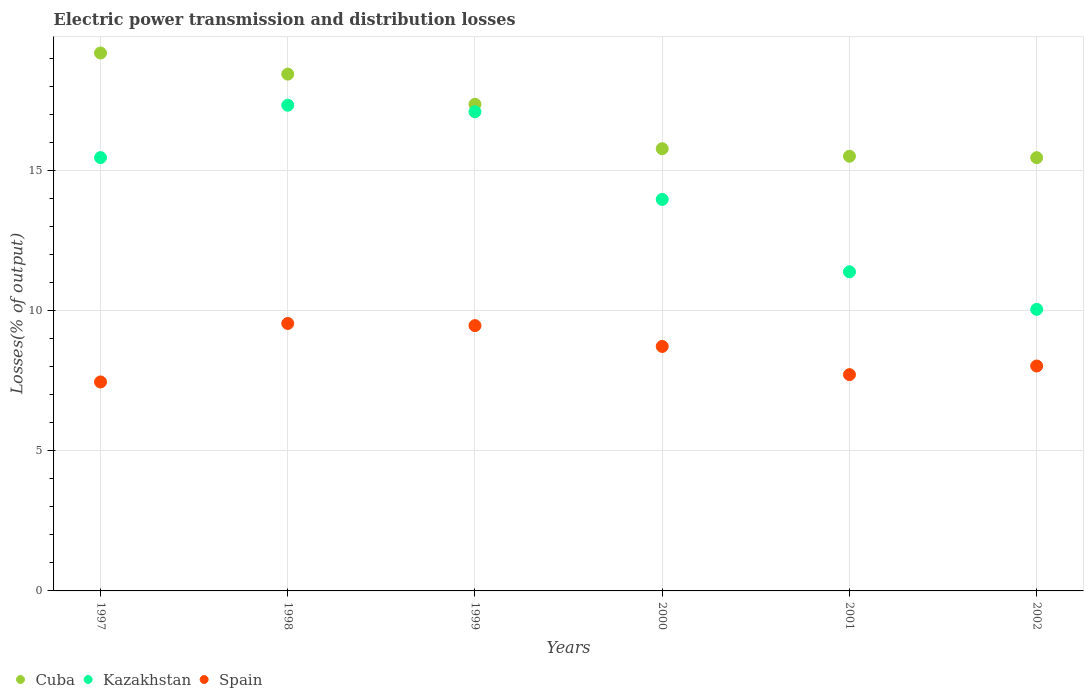What is the electric power transmission and distribution losses in Kazakhstan in 2002?
Your answer should be compact. 10.04. Across all years, what is the maximum electric power transmission and distribution losses in Spain?
Keep it short and to the point. 9.54. Across all years, what is the minimum electric power transmission and distribution losses in Cuba?
Offer a very short reply. 15.45. What is the total electric power transmission and distribution losses in Spain in the graph?
Your answer should be very brief. 50.91. What is the difference between the electric power transmission and distribution losses in Kazakhstan in 1997 and that in 2000?
Ensure brevity in your answer.  1.49. What is the difference between the electric power transmission and distribution losses in Spain in 1999 and the electric power transmission and distribution losses in Cuba in 2000?
Make the answer very short. -6.31. What is the average electric power transmission and distribution losses in Spain per year?
Ensure brevity in your answer.  8.49. In the year 2001, what is the difference between the electric power transmission and distribution losses in Spain and electric power transmission and distribution losses in Cuba?
Ensure brevity in your answer.  -7.79. What is the ratio of the electric power transmission and distribution losses in Spain in 2000 to that in 2001?
Offer a terse response. 1.13. Is the electric power transmission and distribution losses in Kazakhstan in 1999 less than that in 2000?
Your answer should be very brief. No. Is the difference between the electric power transmission and distribution losses in Spain in 1999 and 2001 greater than the difference between the electric power transmission and distribution losses in Cuba in 1999 and 2001?
Keep it short and to the point. No. What is the difference between the highest and the second highest electric power transmission and distribution losses in Spain?
Ensure brevity in your answer.  0.08. What is the difference between the highest and the lowest electric power transmission and distribution losses in Cuba?
Provide a short and direct response. 3.73. In how many years, is the electric power transmission and distribution losses in Kazakhstan greater than the average electric power transmission and distribution losses in Kazakhstan taken over all years?
Your answer should be very brief. 3. Does the electric power transmission and distribution losses in Cuba monotonically increase over the years?
Keep it short and to the point. No. Is the electric power transmission and distribution losses in Spain strictly greater than the electric power transmission and distribution losses in Kazakhstan over the years?
Ensure brevity in your answer.  No. How many dotlines are there?
Your answer should be compact. 3. How many years are there in the graph?
Keep it short and to the point. 6. What is the difference between two consecutive major ticks on the Y-axis?
Your answer should be very brief. 5. Where does the legend appear in the graph?
Give a very brief answer. Bottom left. What is the title of the graph?
Your answer should be compact. Electric power transmission and distribution losses. Does "United States" appear as one of the legend labels in the graph?
Give a very brief answer. No. What is the label or title of the X-axis?
Provide a succinct answer. Years. What is the label or title of the Y-axis?
Your response must be concise. Losses(% of output). What is the Losses(% of output) in Cuba in 1997?
Offer a terse response. 19.19. What is the Losses(% of output) in Kazakhstan in 1997?
Offer a terse response. 15.46. What is the Losses(% of output) of Spain in 1997?
Provide a short and direct response. 7.45. What is the Losses(% of output) of Cuba in 1998?
Your response must be concise. 18.43. What is the Losses(% of output) of Kazakhstan in 1998?
Your answer should be very brief. 17.32. What is the Losses(% of output) of Spain in 1998?
Ensure brevity in your answer.  9.54. What is the Losses(% of output) in Cuba in 1999?
Offer a very short reply. 17.35. What is the Losses(% of output) in Kazakhstan in 1999?
Your answer should be compact. 17.09. What is the Losses(% of output) in Spain in 1999?
Offer a very short reply. 9.46. What is the Losses(% of output) in Cuba in 2000?
Your response must be concise. 15.77. What is the Losses(% of output) in Kazakhstan in 2000?
Make the answer very short. 13.96. What is the Losses(% of output) of Spain in 2000?
Give a very brief answer. 8.72. What is the Losses(% of output) in Cuba in 2001?
Your answer should be very brief. 15.5. What is the Losses(% of output) in Kazakhstan in 2001?
Give a very brief answer. 11.38. What is the Losses(% of output) in Spain in 2001?
Offer a terse response. 7.71. What is the Losses(% of output) in Cuba in 2002?
Your answer should be compact. 15.45. What is the Losses(% of output) of Kazakhstan in 2002?
Offer a terse response. 10.04. What is the Losses(% of output) in Spain in 2002?
Your response must be concise. 8.02. Across all years, what is the maximum Losses(% of output) in Cuba?
Give a very brief answer. 19.19. Across all years, what is the maximum Losses(% of output) in Kazakhstan?
Ensure brevity in your answer.  17.32. Across all years, what is the maximum Losses(% of output) of Spain?
Give a very brief answer. 9.54. Across all years, what is the minimum Losses(% of output) in Cuba?
Your response must be concise. 15.45. Across all years, what is the minimum Losses(% of output) in Kazakhstan?
Keep it short and to the point. 10.04. Across all years, what is the minimum Losses(% of output) of Spain?
Ensure brevity in your answer.  7.45. What is the total Losses(% of output) in Cuba in the graph?
Make the answer very short. 101.7. What is the total Losses(% of output) of Kazakhstan in the graph?
Your answer should be compact. 85.26. What is the total Losses(% of output) of Spain in the graph?
Your response must be concise. 50.91. What is the difference between the Losses(% of output) in Cuba in 1997 and that in 1998?
Your answer should be very brief. 0.75. What is the difference between the Losses(% of output) of Kazakhstan in 1997 and that in 1998?
Your answer should be compact. -1.87. What is the difference between the Losses(% of output) in Spain in 1997 and that in 1998?
Keep it short and to the point. -2.09. What is the difference between the Losses(% of output) in Cuba in 1997 and that in 1999?
Make the answer very short. 1.83. What is the difference between the Losses(% of output) of Kazakhstan in 1997 and that in 1999?
Your response must be concise. -1.64. What is the difference between the Losses(% of output) of Spain in 1997 and that in 1999?
Provide a short and direct response. -2.01. What is the difference between the Losses(% of output) in Cuba in 1997 and that in 2000?
Offer a very short reply. 3.41. What is the difference between the Losses(% of output) in Kazakhstan in 1997 and that in 2000?
Keep it short and to the point. 1.49. What is the difference between the Losses(% of output) of Spain in 1997 and that in 2000?
Make the answer very short. -1.27. What is the difference between the Losses(% of output) of Cuba in 1997 and that in 2001?
Your answer should be very brief. 3.68. What is the difference between the Losses(% of output) in Kazakhstan in 1997 and that in 2001?
Keep it short and to the point. 4.07. What is the difference between the Losses(% of output) of Spain in 1997 and that in 2001?
Ensure brevity in your answer.  -0.26. What is the difference between the Losses(% of output) in Cuba in 1997 and that in 2002?
Give a very brief answer. 3.73. What is the difference between the Losses(% of output) in Kazakhstan in 1997 and that in 2002?
Offer a very short reply. 5.41. What is the difference between the Losses(% of output) of Spain in 1997 and that in 2002?
Your answer should be very brief. -0.57. What is the difference between the Losses(% of output) in Cuba in 1998 and that in 1999?
Your answer should be compact. 1.08. What is the difference between the Losses(% of output) in Kazakhstan in 1998 and that in 1999?
Provide a short and direct response. 0.23. What is the difference between the Losses(% of output) of Spain in 1998 and that in 1999?
Provide a succinct answer. 0.08. What is the difference between the Losses(% of output) in Cuba in 1998 and that in 2000?
Provide a succinct answer. 2.66. What is the difference between the Losses(% of output) of Kazakhstan in 1998 and that in 2000?
Ensure brevity in your answer.  3.36. What is the difference between the Losses(% of output) of Spain in 1998 and that in 2000?
Keep it short and to the point. 0.82. What is the difference between the Losses(% of output) of Cuba in 1998 and that in 2001?
Ensure brevity in your answer.  2.93. What is the difference between the Losses(% of output) of Kazakhstan in 1998 and that in 2001?
Offer a terse response. 5.94. What is the difference between the Losses(% of output) in Spain in 1998 and that in 2001?
Your answer should be compact. 1.82. What is the difference between the Losses(% of output) in Cuba in 1998 and that in 2002?
Ensure brevity in your answer.  2.98. What is the difference between the Losses(% of output) in Kazakhstan in 1998 and that in 2002?
Offer a very short reply. 7.28. What is the difference between the Losses(% of output) of Spain in 1998 and that in 2002?
Provide a succinct answer. 1.52. What is the difference between the Losses(% of output) in Cuba in 1999 and that in 2000?
Provide a succinct answer. 1.58. What is the difference between the Losses(% of output) in Kazakhstan in 1999 and that in 2000?
Your answer should be very brief. 3.13. What is the difference between the Losses(% of output) of Spain in 1999 and that in 2000?
Your answer should be very brief. 0.74. What is the difference between the Losses(% of output) of Cuba in 1999 and that in 2001?
Your answer should be very brief. 1.85. What is the difference between the Losses(% of output) of Kazakhstan in 1999 and that in 2001?
Provide a succinct answer. 5.71. What is the difference between the Losses(% of output) in Spain in 1999 and that in 2001?
Offer a very short reply. 1.75. What is the difference between the Losses(% of output) of Cuba in 1999 and that in 2002?
Provide a short and direct response. 1.9. What is the difference between the Losses(% of output) in Kazakhstan in 1999 and that in 2002?
Make the answer very short. 7.05. What is the difference between the Losses(% of output) in Spain in 1999 and that in 2002?
Provide a short and direct response. 1.44. What is the difference between the Losses(% of output) in Cuba in 2000 and that in 2001?
Provide a short and direct response. 0.27. What is the difference between the Losses(% of output) in Kazakhstan in 2000 and that in 2001?
Your response must be concise. 2.58. What is the difference between the Losses(% of output) of Cuba in 2000 and that in 2002?
Your answer should be compact. 0.32. What is the difference between the Losses(% of output) of Kazakhstan in 2000 and that in 2002?
Give a very brief answer. 3.92. What is the difference between the Losses(% of output) of Spain in 2000 and that in 2002?
Your response must be concise. 0.7. What is the difference between the Losses(% of output) in Cuba in 2001 and that in 2002?
Offer a terse response. 0.05. What is the difference between the Losses(% of output) of Kazakhstan in 2001 and that in 2002?
Make the answer very short. 1.34. What is the difference between the Losses(% of output) of Spain in 2001 and that in 2002?
Offer a terse response. -0.31. What is the difference between the Losses(% of output) in Cuba in 1997 and the Losses(% of output) in Kazakhstan in 1998?
Your response must be concise. 1.86. What is the difference between the Losses(% of output) in Cuba in 1997 and the Losses(% of output) in Spain in 1998?
Keep it short and to the point. 9.65. What is the difference between the Losses(% of output) of Kazakhstan in 1997 and the Losses(% of output) of Spain in 1998?
Offer a very short reply. 5.92. What is the difference between the Losses(% of output) of Cuba in 1997 and the Losses(% of output) of Kazakhstan in 1999?
Your answer should be compact. 2.09. What is the difference between the Losses(% of output) of Cuba in 1997 and the Losses(% of output) of Spain in 1999?
Ensure brevity in your answer.  9.72. What is the difference between the Losses(% of output) of Kazakhstan in 1997 and the Losses(% of output) of Spain in 1999?
Offer a very short reply. 5.99. What is the difference between the Losses(% of output) in Cuba in 1997 and the Losses(% of output) in Kazakhstan in 2000?
Ensure brevity in your answer.  5.22. What is the difference between the Losses(% of output) of Cuba in 1997 and the Losses(% of output) of Spain in 2000?
Give a very brief answer. 10.46. What is the difference between the Losses(% of output) in Kazakhstan in 1997 and the Losses(% of output) in Spain in 2000?
Make the answer very short. 6.74. What is the difference between the Losses(% of output) in Cuba in 1997 and the Losses(% of output) in Kazakhstan in 2001?
Give a very brief answer. 7.8. What is the difference between the Losses(% of output) in Cuba in 1997 and the Losses(% of output) in Spain in 2001?
Ensure brevity in your answer.  11.47. What is the difference between the Losses(% of output) of Kazakhstan in 1997 and the Losses(% of output) of Spain in 2001?
Your answer should be very brief. 7.74. What is the difference between the Losses(% of output) of Cuba in 1997 and the Losses(% of output) of Kazakhstan in 2002?
Provide a short and direct response. 9.14. What is the difference between the Losses(% of output) of Cuba in 1997 and the Losses(% of output) of Spain in 2002?
Give a very brief answer. 11.16. What is the difference between the Losses(% of output) in Kazakhstan in 1997 and the Losses(% of output) in Spain in 2002?
Provide a succinct answer. 7.43. What is the difference between the Losses(% of output) in Cuba in 1998 and the Losses(% of output) in Kazakhstan in 1999?
Your answer should be compact. 1.34. What is the difference between the Losses(% of output) of Cuba in 1998 and the Losses(% of output) of Spain in 1999?
Ensure brevity in your answer.  8.97. What is the difference between the Losses(% of output) in Kazakhstan in 1998 and the Losses(% of output) in Spain in 1999?
Keep it short and to the point. 7.86. What is the difference between the Losses(% of output) of Cuba in 1998 and the Losses(% of output) of Kazakhstan in 2000?
Ensure brevity in your answer.  4.47. What is the difference between the Losses(% of output) of Cuba in 1998 and the Losses(% of output) of Spain in 2000?
Make the answer very short. 9.71. What is the difference between the Losses(% of output) in Kazakhstan in 1998 and the Losses(% of output) in Spain in 2000?
Make the answer very short. 8.6. What is the difference between the Losses(% of output) of Cuba in 1998 and the Losses(% of output) of Kazakhstan in 2001?
Provide a short and direct response. 7.05. What is the difference between the Losses(% of output) in Cuba in 1998 and the Losses(% of output) in Spain in 2001?
Provide a succinct answer. 10.72. What is the difference between the Losses(% of output) of Kazakhstan in 1998 and the Losses(% of output) of Spain in 2001?
Your response must be concise. 9.61. What is the difference between the Losses(% of output) in Cuba in 1998 and the Losses(% of output) in Kazakhstan in 2002?
Provide a succinct answer. 8.39. What is the difference between the Losses(% of output) in Cuba in 1998 and the Losses(% of output) in Spain in 2002?
Your answer should be compact. 10.41. What is the difference between the Losses(% of output) of Kazakhstan in 1998 and the Losses(% of output) of Spain in 2002?
Keep it short and to the point. 9.3. What is the difference between the Losses(% of output) in Cuba in 1999 and the Losses(% of output) in Kazakhstan in 2000?
Provide a succinct answer. 3.39. What is the difference between the Losses(% of output) in Cuba in 1999 and the Losses(% of output) in Spain in 2000?
Your answer should be very brief. 8.63. What is the difference between the Losses(% of output) of Kazakhstan in 1999 and the Losses(% of output) of Spain in 2000?
Your answer should be very brief. 8.37. What is the difference between the Losses(% of output) in Cuba in 1999 and the Losses(% of output) in Kazakhstan in 2001?
Your response must be concise. 5.97. What is the difference between the Losses(% of output) in Cuba in 1999 and the Losses(% of output) in Spain in 2001?
Your response must be concise. 9.64. What is the difference between the Losses(% of output) in Kazakhstan in 1999 and the Losses(% of output) in Spain in 2001?
Your response must be concise. 9.38. What is the difference between the Losses(% of output) of Cuba in 1999 and the Losses(% of output) of Kazakhstan in 2002?
Make the answer very short. 7.31. What is the difference between the Losses(% of output) in Cuba in 1999 and the Losses(% of output) in Spain in 2002?
Keep it short and to the point. 9.33. What is the difference between the Losses(% of output) of Kazakhstan in 1999 and the Losses(% of output) of Spain in 2002?
Provide a short and direct response. 9.07. What is the difference between the Losses(% of output) of Cuba in 2000 and the Losses(% of output) of Kazakhstan in 2001?
Your response must be concise. 4.39. What is the difference between the Losses(% of output) of Cuba in 2000 and the Losses(% of output) of Spain in 2001?
Provide a succinct answer. 8.06. What is the difference between the Losses(% of output) of Kazakhstan in 2000 and the Losses(% of output) of Spain in 2001?
Your answer should be compact. 6.25. What is the difference between the Losses(% of output) in Cuba in 2000 and the Losses(% of output) in Kazakhstan in 2002?
Keep it short and to the point. 5.73. What is the difference between the Losses(% of output) of Cuba in 2000 and the Losses(% of output) of Spain in 2002?
Provide a short and direct response. 7.75. What is the difference between the Losses(% of output) in Kazakhstan in 2000 and the Losses(% of output) in Spain in 2002?
Provide a short and direct response. 5.94. What is the difference between the Losses(% of output) in Cuba in 2001 and the Losses(% of output) in Kazakhstan in 2002?
Keep it short and to the point. 5.46. What is the difference between the Losses(% of output) of Cuba in 2001 and the Losses(% of output) of Spain in 2002?
Ensure brevity in your answer.  7.48. What is the difference between the Losses(% of output) in Kazakhstan in 2001 and the Losses(% of output) in Spain in 2002?
Give a very brief answer. 3.36. What is the average Losses(% of output) of Cuba per year?
Provide a succinct answer. 16.95. What is the average Losses(% of output) of Kazakhstan per year?
Keep it short and to the point. 14.21. What is the average Losses(% of output) of Spain per year?
Your response must be concise. 8.49. In the year 1997, what is the difference between the Losses(% of output) of Cuba and Losses(% of output) of Kazakhstan?
Keep it short and to the point. 3.73. In the year 1997, what is the difference between the Losses(% of output) in Cuba and Losses(% of output) in Spain?
Your response must be concise. 11.73. In the year 1997, what is the difference between the Losses(% of output) in Kazakhstan and Losses(% of output) in Spain?
Your answer should be compact. 8. In the year 1998, what is the difference between the Losses(% of output) in Cuba and Losses(% of output) in Kazakhstan?
Offer a terse response. 1.11. In the year 1998, what is the difference between the Losses(% of output) of Cuba and Losses(% of output) of Spain?
Keep it short and to the point. 8.89. In the year 1998, what is the difference between the Losses(% of output) of Kazakhstan and Losses(% of output) of Spain?
Keep it short and to the point. 7.79. In the year 1999, what is the difference between the Losses(% of output) of Cuba and Losses(% of output) of Kazakhstan?
Your answer should be compact. 0.26. In the year 1999, what is the difference between the Losses(% of output) of Cuba and Losses(% of output) of Spain?
Make the answer very short. 7.89. In the year 1999, what is the difference between the Losses(% of output) of Kazakhstan and Losses(% of output) of Spain?
Ensure brevity in your answer.  7.63. In the year 2000, what is the difference between the Losses(% of output) in Cuba and Losses(% of output) in Kazakhstan?
Offer a very short reply. 1.81. In the year 2000, what is the difference between the Losses(% of output) in Cuba and Losses(% of output) in Spain?
Your answer should be compact. 7.05. In the year 2000, what is the difference between the Losses(% of output) of Kazakhstan and Losses(% of output) of Spain?
Provide a succinct answer. 5.24. In the year 2001, what is the difference between the Losses(% of output) in Cuba and Losses(% of output) in Kazakhstan?
Give a very brief answer. 4.12. In the year 2001, what is the difference between the Losses(% of output) in Cuba and Losses(% of output) in Spain?
Your answer should be compact. 7.79. In the year 2001, what is the difference between the Losses(% of output) of Kazakhstan and Losses(% of output) of Spain?
Keep it short and to the point. 3.67. In the year 2002, what is the difference between the Losses(% of output) of Cuba and Losses(% of output) of Kazakhstan?
Your answer should be very brief. 5.41. In the year 2002, what is the difference between the Losses(% of output) in Cuba and Losses(% of output) in Spain?
Provide a short and direct response. 7.43. In the year 2002, what is the difference between the Losses(% of output) in Kazakhstan and Losses(% of output) in Spain?
Offer a terse response. 2.02. What is the ratio of the Losses(% of output) of Cuba in 1997 to that in 1998?
Your answer should be compact. 1.04. What is the ratio of the Losses(% of output) of Kazakhstan in 1997 to that in 1998?
Provide a short and direct response. 0.89. What is the ratio of the Losses(% of output) of Spain in 1997 to that in 1998?
Your answer should be compact. 0.78. What is the ratio of the Losses(% of output) of Cuba in 1997 to that in 1999?
Your answer should be compact. 1.11. What is the ratio of the Losses(% of output) in Kazakhstan in 1997 to that in 1999?
Give a very brief answer. 0.9. What is the ratio of the Losses(% of output) in Spain in 1997 to that in 1999?
Make the answer very short. 0.79. What is the ratio of the Losses(% of output) in Cuba in 1997 to that in 2000?
Your answer should be very brief. 1.22. What is the ratio of the Losses(% of output) of Kazakhstan in 1997 to that in 2000?
Give a very brief answer. 1.11. What is the ratio of the Losses(% of output) of Spain in 1997 to that in 2000?
Keep it short and to the point. 0.85. What is the ratio of the Losses(% of output) in Cuba in 1997 to that in 2001?
Make the answer very short. 1.24. What is the ratio of the Losses(% of output) of Kazakhstan in 1997 to that in 2001?
Give a very brief answer. 1.36. What is the ratio of the Losses(% of output) of Spain in 1997 to that in 2001?
Give a very brief answer. 0.97. What is the ratio of the Losses(% of output) of Cuba in 1997 to that in 2002?
Provide a short and direct response. 1.24. What is the ratio of the Losses(% of output) in Kazakhstan in 1997 to that in 2002?
Offer a very short reply. 1.54. What is the ratio of the Losses(% of output) in Spain in 1997 to that in 2002?
Offer a very short reply. 0.93. What is the ratio of the Losses(% of output) of Cuba in 1998 to that in 1999?
Offer a very short reply. 1.06. What is the ratio of the Losses(% of output) of Kazakhstan in 1998 to that in 1999?
Offer a terse response. 1.01. What is the ratio of the Losses(% of output) in Cuba in 1998 to that in 2000?
Provide a succinct answer. 1.17. What is the ratio of the Losses(% of output) of Kazakhstan in 1998 to that in 2000?
Your answer should be compact. 1.24. What is the ratio of the Losses(% of output) in Spain in 1998 to that in 2000?
Give a very brief answer. 1.09. What is the ratio of the Losses(% of output) in Cuba in 1998 to that in 2001?
Keep it short and to the point. 1.19. What is the ratio of the Losses(% of output) in Kazakhstan in 1998 to that in 2001?
Provide a succinct answer. 1.52. What is the ratio of the Losses(% of output) of Spain in 1998 to that in 2001?
Give a very brief answer. 1.24. What is the ratio of the Losses(% of output) of Cuba in 1998 to that in 2002?
Give a very brief answer. 1.19. What is the ratio of the Losses(% of output) in Kazakhstan in 1998 to that in 2002?
Offer a terse response. 1.73. What is the ratio of the Losses(% of output) in Spain in 1998 to that in 2002?
Provide a short and direct response. 1.19. What is the ratio of the Losses(% of output) in Cuba in 1999 to that in 2000?
Your answer should be very brief. 1.1. What is the ratio of the Losses(% of output) in Kazakhstan in 1999 to that in 2000?
Your answer should be very brief. 1.22. What is the ratio of the Losses(% of output) of Spain in 1999 to that in 2000?
Provide a short and direct response. 1.09. What is the ratio of the Losses(% of output) in Cuba in 1999 to that in 2001?
Provide a short and direct response. 1.12. What is the ratio of the Losses(% of output) of Kazakhstan in 1999 to that in 2001?
Provide a succinct answer. 1.5. What is the ratio of the Losses(% of output) in Spain in 1999 to that in 2001?
Provide a succinct answer. 1.23. What is the ratio of the Losses(% of output) in Cuba in 1999 to that in 2002?
Offer a very short reply. 1.12. What is the ratio of the Losses(% of output) of Kazakhstan in 1999 to that in 2002?
Your answer should be compact. 1.7. What is the ratio of the Losses(% of output) of Spain in 1999 to that in 2002?
Ensure brevity in your answer.  1.18. What is the ratio of the Losses(% of output) of Cuba in 2000 to that in 2001?
Keep it short and to the point. 1.02. What is the ratio of the Losses(% of output) of Kazakhstan in 2000 to that in 2001?
Provide a succinct answer. 1.23. What is the ratio of the Losses(% of output) of Spain in 2000 to that in 2001?
Give a very brief answer. 1.13. What is the ratio of the Losses(% of output) in Cuba in 2000 to that in 2002?
Ensure brevity in your answer.  1.02. What is the ratio of the Losses(% of output) of Kazakhstan in 2000 to that in 2002?
Ensure brevity in your answer.  1.39. What is the ratio of the Losses(% of output) of Spain in 2000 to that in 2002?
Provide a succinct answer. 1.09. What is the ratio of the Losses(% of output) of Kazakhstan in 2001 to that in 2002?
Provide a short and direct response. 1.13. What is the ratio of the Losses(% of output) in Spain in 2001 to that in 2002?
Your answer should be compact. 0.96. What is the difference between the highest and the second highest Losses(% of output) in Cuba?
Provide a short and direct response. 0.75. What is the difference between the highest and the second highest Losses(% of output) of Kazakhstan?
Provide a short and direct response. 0.23. What is the difference between the highest and the second highest Losses(% of output) in Spain?
Provide a short and direct response. 0.08. What is the difference between the highest and the lowest Losses(% of output) in Cuba?
Your answer should be compact. 3.73. What is the difference between the highest and the lowest Losses(% of output) in Kazakhstan?
Offer a very short reply. 7.28. What is the difference between the highest and the lowest Losses(% of output) of Spain?
Ensure brevity in your answer.  2.09. 